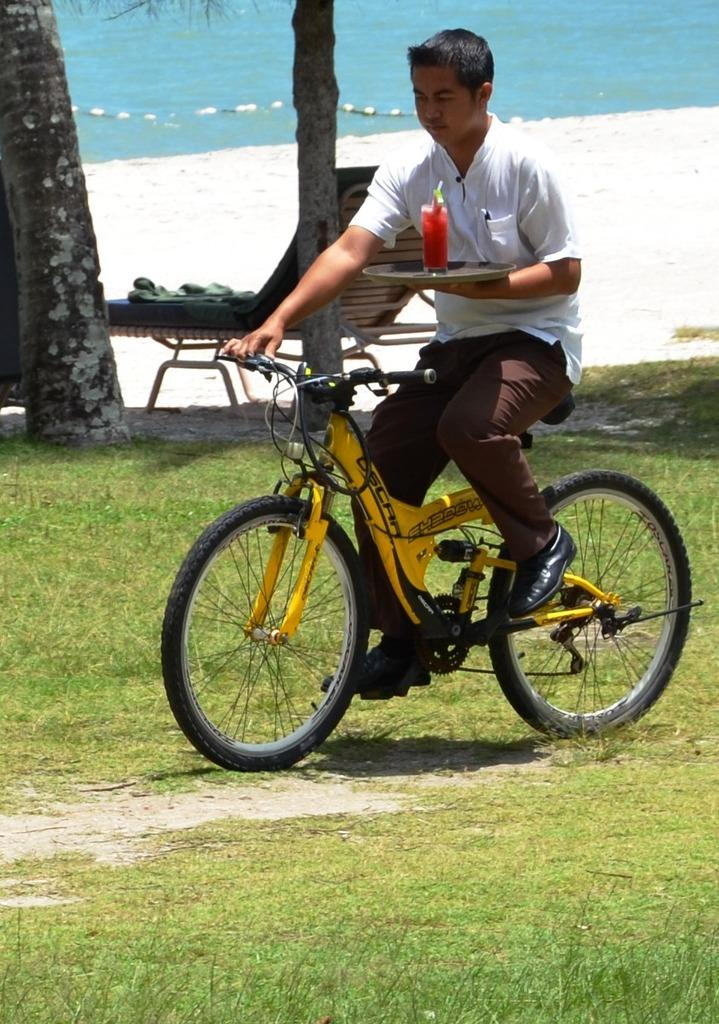What is the man in the image doing? The man is sitting on a bicycle in the image. What is the ground surface like in the image? The ground is covered with grass. Who else is present in the image besides the man on the bicycle? There is a man holding a plate in the image. What is on the plate that the man is holding? There is a juice glass on the plate. What type of bulb is being used to illuminate the border in the image? There is no mention of a bulb or border in the image; it features a man sitting on a bicycle and another man holding a plate with a juice glass. 